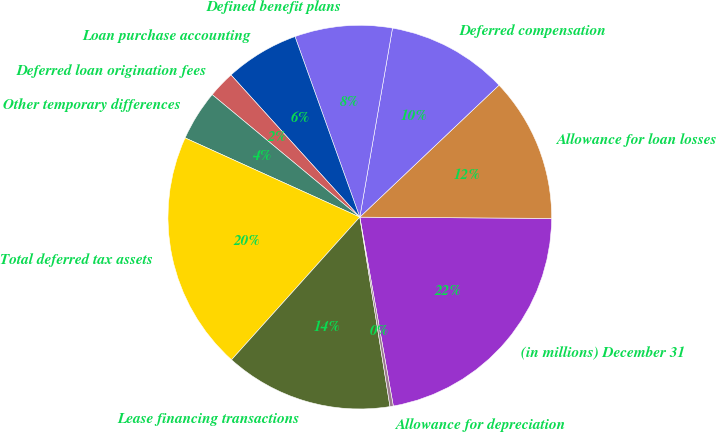Convert chart to OTSL. <chart><loc_0><loc_0><loc_500><loc_500><pie_chart><fcel>(in millions) December 31<fcel>Allowance for loan losses<fcel>Deferred compensation<fcel>Defined benefit plans<fcel>Loan purchase accounting<fcel>Deferred loan origination fees<fcel>Other temporary differences<fcel>Total deferred tax assets<fcel>Lease financing transactions<fcel>Allowance for depreciation<nl><fcel>22.1%<fcel>12.18%<fcel>10.2%<fcel>8.21%<fcel>6.23%<fcel>2.26%<fcel>4.25%<fcel>20.12%<fcel>14.17%<fcel>0.28%<nl></chart> 